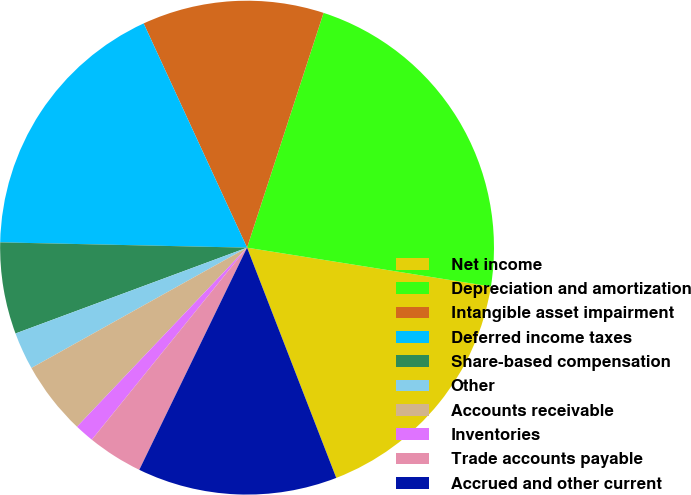Convert chart to OTSL. <chart><loc_0><loc_0><loc_500><loc_500><pie_chart><fcel>Net income<fcel>Depreciation and amortization<fcel>Intangible asset impairment<fcel>Deferred income taxes<fcel>Share-based compensation<fcel>Other<fcel>Accounts receivable<fcel>Inventories<fcel>Trade accounts payable<fcel>Accrued and other current<nl><fcel>16.6%<fcel>22.5%<fcel>11.89%<fcel>17.78%<fcel>5.99%<fcel>2.45%<fcel>4.81%<fcel>1.27%<fcel>3.63%<fcel>13.07%<nl></chart> 